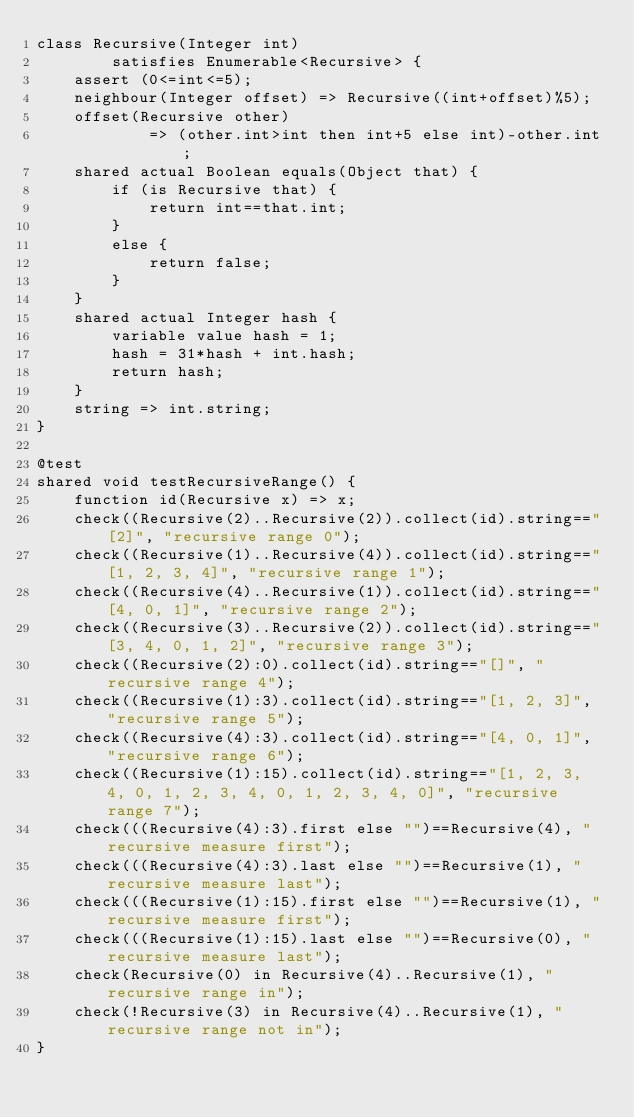Convert code to text. <code><loc_0><loc_0><loc_500><loc_500><_Ceylon_>class Recursive(Integer int) 
        satisfies Enumerable<Recursive> {
    assert (0<=int<=5);
    neighbour(Integer offset) => Recursive((int+offset)%5);
    offset(Recursive other) 
            => (other.int>int then int+5 else int)-other.int;
    shared actual Boolean equals(Object that) {
        if (is Recursive that) {
            return int==that.int;
        }
        else {
            return false;
        }
    }
    shared actual Integer hash {
        variable value hash = 1;
        hash = 31*hash + int.hash;
        return hash;
    }
    string => int.string;
}

@test
shared void testRecursiveRange() {
    function id(Recursive x) => x;
    check((Recursive(2)..Recursive(2)).collect(id).string=="[2]", "recursive range 0");
    check((Recursive(1)..Recursive(4)).collect(id).string=="[1, 2, 3, 4]", "recursive range 1");
    check((Recursive(4)..Recursive(1)).collect(id).string=="[4, 0, 1]", "recursive range 2");
    check((Recursive(3)..Recursive(2)).collect(id).string=="[3, 4, 0, 1, 2]", "recursive range 3");
    check((Recursive(2):0).collect(id).string=="[]", "recursive range 4");
    check((Recursive(1):3).collect(id).string=="[1, 2, 3]", "recursive range 5");
    check((Recursive(4):3).collect(id).string=="[4, 0, 1]", "recursive range 6");
    check((Recursive(1):15).collect(id).string=="[1, 2, 3, 4, 0, 1, 2, 3, 4, 0, 1, 2, 3, 4, 0]", "recursive range 7");
    check(((Recursive(4):3).first else "")==Recursive(4), "recursive measure first");
    check(((Recursive(4):3).last else "")==Recursive(1), "recursive measure last");
    check(((Recursive(1):15).first else "")==Recursive(1), "recursive measure first");
    check(((Recursive(1):15).last else "")==Recursive(0), "recursive measure last");
    check(Recursive(0) in Recursive(4)..Recursive(1), "recursive range in");
    check(!Recursive(3) in Recursive(4)..Recursive(1), "recursive range not in");
}</code> 